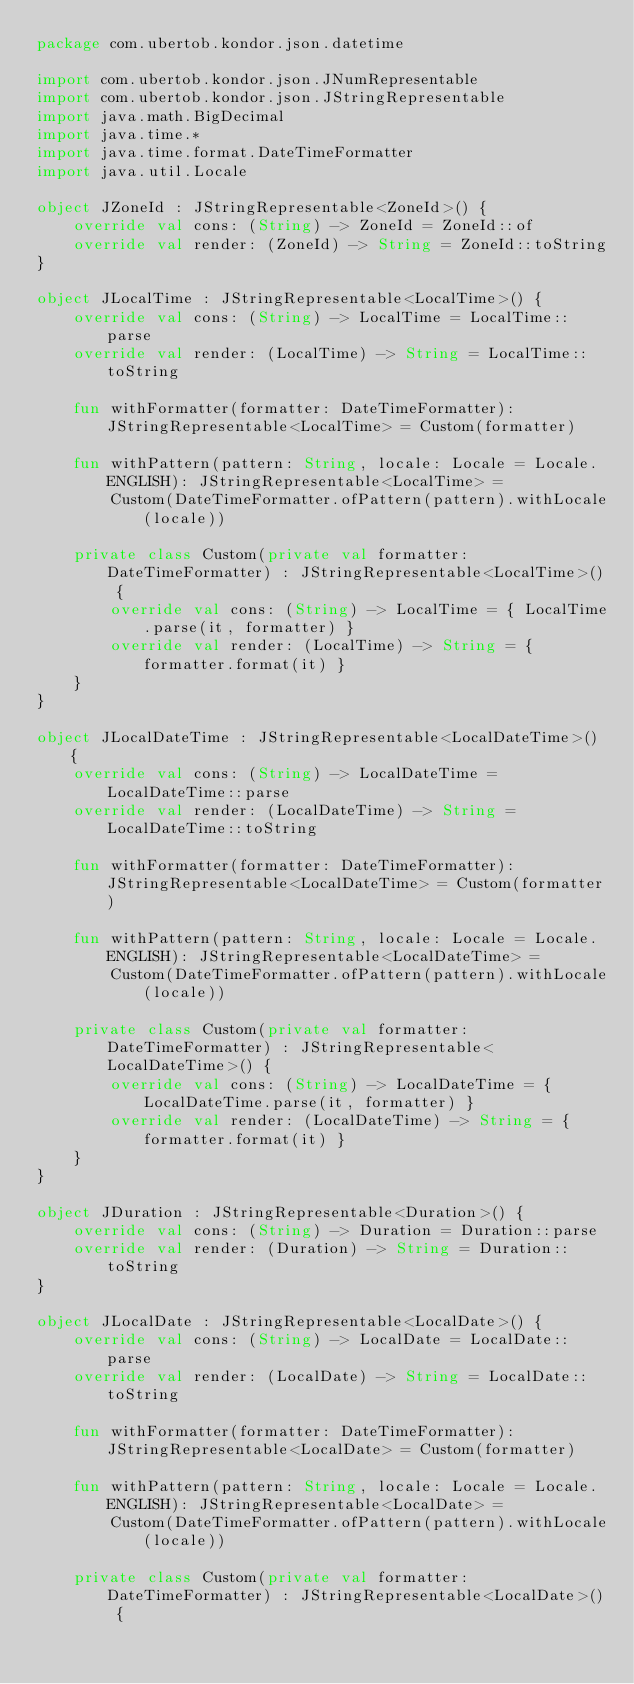Convert code to text. <code><loc_0><loc_0><loc_500><loc_500><_Kotlin_>package com.ubertob.kondor.json.datetime

import com.ubertob.kondor.json.JNumRepresentable
import com.ubertob.kondor.json.JStringRepresentable
import java.math.BigDecimal
import java.time.*
import java.time.format.DateTimeFormatter
import java.util.Locale

object JZoneId : JStringRepresentable<ZoneId>() {
    override val cons: (String) -> ZoneId = ZoneId::of
    override val render: (ZoneId) -> String = ZoneId::toString
}

object JLocalTime : JStringRepresentable<LocalTime>() {
    override val cons: (String) -> LocalTime = LocalTime::parse
    override val render: (LocalTime) -> String = LocalTime::toString

    fun withFormatter(formatter: DateTimeFormatter): JStringRepresentable<LocalTime> = Custom(formatter)

    fun withPattern(pattern: String, locale: Locale = Locale.ENGLISH): JStringRepresentable<LocalTime> =
        Custom(DateTimeFormatter.ofPattern(pattern).withLocale(locale))

    private class Custom(private val formatter: DateTimeFormatter) : JStringRepresentable<LocalTime>() {
        override val cons: (String) -> LocalTime = { LocalTime.parse(it, formatter) }
        override val render: (LocalTime) -> String = { formatter.format(it) }
    }
}

object JLocalDateTime : JStringRepresentable<LocalDateTime>() {
    override val cons: (String) -> LocalDateTime = LocalDateTime::parse
    override val render: (LocalDateTime) -> String = LocalDateTime::toString

    fun withFormatter(formatter: DateTimeFormatter): JStringRepresentable<LocalDateTime> = Custom(formatter)

    fun withPattern(pattern: String, locale: Locale = Locale.ENGLISH): JStringRepresentable<LocalDateTime> =
        Custom(DateTimeFormatter.ofPattern(pattern).withLocale(locale))

    private class Custom(private val formatter: DateTimeFormatter) : JStringRepresentable<LocalDateTime>() {
        override val cons: (String) -> LocalDateTime = { LocalDateTime.parse(it, formatter) }
        override val render: (LocalDateTime) -> String = { formatter.format(it) }
    }
}

object JDuration : JStringRepresentable<Duration>() {
    override val cons: (String) -> Duration = Duration::parse
    override val render: (Duration) -> String = Duration::toString
}

object JLocalDate : JStringRepresentable<LocalDate>() {
    override val cons: (String) -> LocalDate = LocalDate::parse
    override val render: (LocalDate) -> String = LocalDate::toString

    fun withFormatter(formatter: DateTimeFormatter): JStringRepresentable<LocalDate> = Custom(formatter)

    fun withPattern(pattern: String, locale: Locale = Locale.ENGLISH): JStringRepresentable<LocalDate> =
        Custom(DateTimeFormatter.ofPattern(pattern).withLocale(locale))

    private class Custom(private val formatter: DateTimeFormatter) : JStringRepresentable<LocalDate>() {</code> 